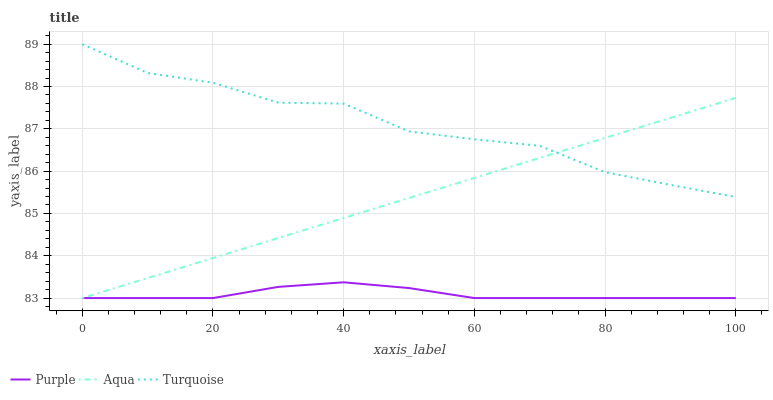Does Purple have the minimum area under the curve?
Answer yes or no. Yes. Does Turquoise have the maximum area under the curve?
Answer yes or no. Yes. Does Aqua have the minimum area under the curve?
Answer yes or no. No. Does Aqua have the maximum area under the curve?
Answer yes or no. No. Is Aqua the smoothest?
Answer yes or no. Yes. Is Turquoise the roughest?
Answer yes or no. Yes. Is Turquoise the smoothest?
Answer yes or no. No. Is Aqua the roughest?
Answer yes or no. No. Does Purple have the lowest value?
Answer yes or no. Yes. Does Turquoise have the lowest value?
Answer yes or no. No. Does Turquoise have the highest value?
Answer yes or no. Yes. Does Aqua have the highest value?
Answer yes or no. No. Is Purple less than Turquoise?
Answer yes or no. Yes. Is Turquoise greater than Purple?
Answer yes or no. Yes. Does Purple intersect Aqua?
Answer yes or no. Yes. Is Purple less than Aqua?
Answer yes or no. No. Is Purple greater than Aqua?
Answer yes or no. No. Does Purple intersect Turquoise?
Answer yes or no. No. 